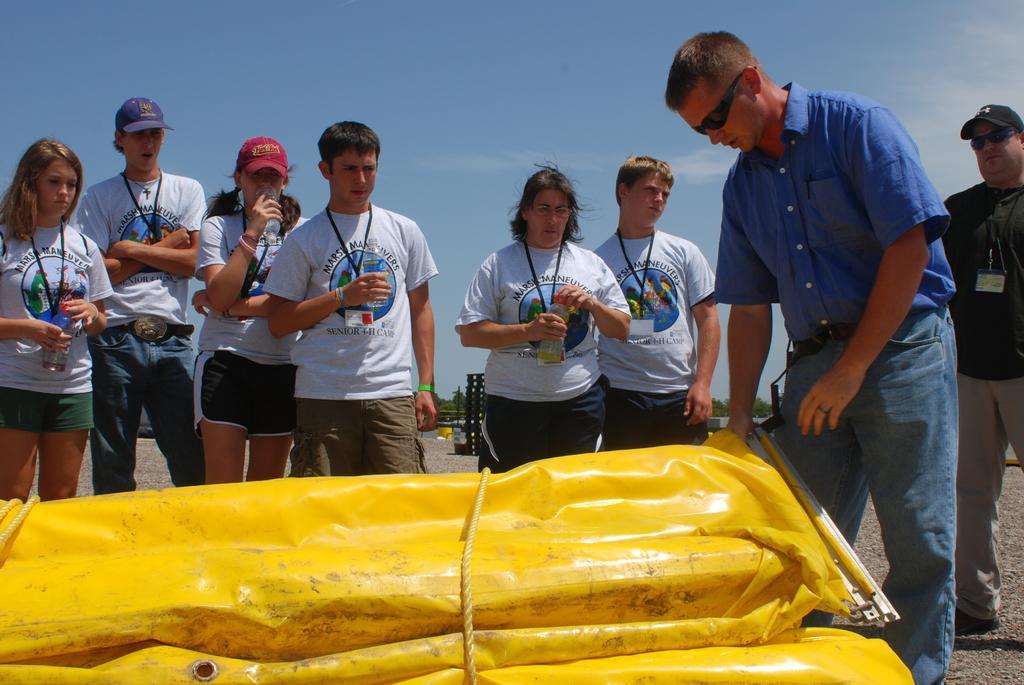In one or two sentences, can you explain what this image depicts? In the right side a man is standing, he wore a blue color shirt and observing this and yellow color thing and few people are standing at here and looking at this thing. They wore white color t-shirts, at the top it's a sunny sky. 